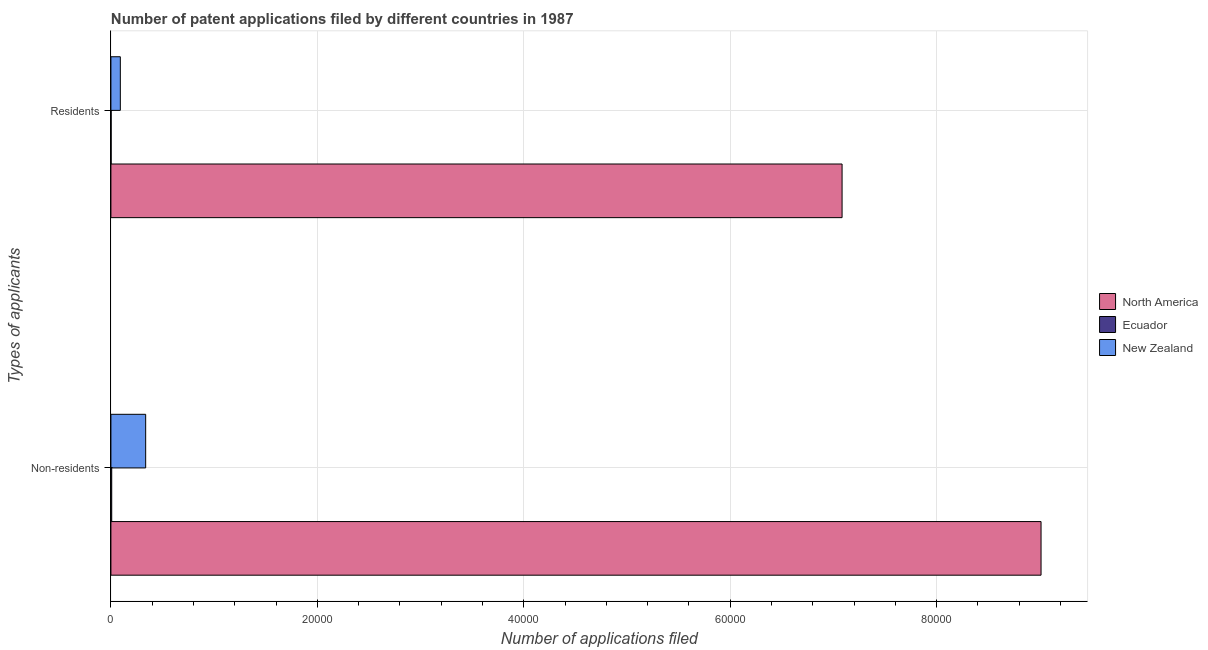How many different coloured bars are there?
Give a very brief answer. 3. How many bars are there on the 2nd tick from the top?
Give a very brief answer. 3. How many bars are there on the 2nd tick from the bottom?
Keep it short and to the point. 3. What is the label of the 1st group of bars from the top?
Keep it short and to the point. Residents. What is the number of patent applications by non residents in North America?
Make the answer very short. 9.01e+04. Across all countries, what is the maximum number of patent applications by non residents?
Provide a succinct answer. 9.01e+04. Across all countries, what is the minimum number of patent applications by residents?
Provide a succinct answer. 21. In which country was the number of patent applications by non residents minimum?
Your answer should be compact. Ecuador. What is the total number of patent applications by non residents in the graph?
Make the answer very short. 9.36e+04. What is the difference between the number of patent applications by residents in North America and that in Ecuador?
Keep it short and to the point. 7.08e+04. What is the difference between the number of patent applications by residents in New Zealand and the number of patent applications by non residents in Ecuador?
Your answer should be very brief. 834. What is the average number of patent applications by non residents per country?
Provide a succinct answer. 3.12e+04. What is the difference between the number of patent applications by non residents and number of patent applications by residents in Ecuador?
Give a very brief answer. 57. What is the ratio of the number of patent applications by residents in New Zealand to that in Ecuador?
Your answer should be compact. 43.43. Is the number of patent applications by non residents in Ecuador less than that in North America?
Offer a very short reply. Yes. What does the 1st bar from the top in Residents represents?
Make the answer very short. New Zealand. What does the 3rd bar from the bottom in Non-residents represents?
Offer a terse response. New Zealand. How many bars are there?
Offer a terse response. 6. How many countries are there in the graph?
Make the answer very short. 3. What is the difference between two consecutive major ticks on the X-axis?
Give a very brief answer. 2.00e+04. Does the graph contain any zero values?
Provide a short and direct response. No. Does the graph contain grids?
Keep it short and to the point. Yes. Where does the legend appear in the graph?
Make the answer very short. Center right. How many legend labels are there?
Ensure brevity in your answer.  3. How are the legend labels stacked?
Your answer should be very brief. Vertical. What is the title of the graph?
Keep it short and to the point. Number of patent applications filed by different countries in 1987. What is the label or title of the X-axis?
Make the answer very short. Number of applications filed. What is the label or title of the Y-axis?
Provide a succinct answer. Types of applicants. What is the Number of applications filed in North America in Non-residents?
Provide a short and direct response. 9.01e+04. What is the Number of applications filed in Ecuador in Non-residents?
Keep it short and to the point. 78. What is the Number of applications filed of New Zealand in Non-residents?
Provide a succinct answer. 3368. What is the Number of applications filed in North America in Residents?
Keep it short and to the point. 7.08e+04. What is the Number of applications filed in Ecuador in Residents?
Ensure brevity in your answer.  21. What is the Number of applications filed in New Zealand in Residents?
Give a very brief answer. 912. Across all Types of applicants, what is the maximum Number of applications filed in North America?
Keep it short and to the point. 9.01e+04. Across all Types of applicants, what is the maximum Number of applications filed of Ecuador?
Ensure brevity in your answer.  78. Across all Types of applicants, what is the maximum Number of applications filed in New Zealand?
Make the answer very short. 3368. Across all Types of applicants, what is the minimum Number of applications filed in North America?
Provide a short and direct response. 7.08e+04. Across all Types of applicants, what is the minimum Number of applications filed of Ecuador?
Your answer should be very brief. 21. Across all Types of applicants, what is the minimum Number of applications filed in New Zealand?
Keep it short and to the point. 912. What is the total Number of applications filed of North America in the graph?
Keep it short and to the point. 1.61e+05. What is the total Number of applications filed in Ecuador in the graph?
Offer a very short reply. 99. What is the total Number of applications filed in New Zealand in the graph?
Your answer should be compact. 4280. What is the difference between the Number of applications filed of North America in Non-residents and that in Residents?
Your answer should be compact. 1.93e+04. What is the difference between the Number of applications filed of New Zealand in Non-residents and that in Residents?
Give a very brief answer. 2456. What is the difference between the Number of applications filed of North America in Non-residents and the Number of applications filed of Ecuador in Residents?
Your answer should be very brief. 9.01e+04. What is the difference between the Number of applications filed of North America in Non-residents and the Number of applications filed of New Zealand in Residents?
Your response must be concise. 8.92e+04. What is the difference between the Number of applications filed in Ecuador in Non-residents and the Number of applications filed in New Zealand in Residents?
Ensure brevity in your answer.  -834. What is the average Number of applications filed of North America per Types of applicants?
Provide a succinct answer. 8.05e+04. What is the average Number of applications filed of Ecuador per Types of applicants?
Give a very brief answer. 49.5. What is the average Number of applications filed of New Zealand per Types of applicants?
Keep it short and to the point. 2140. What is the difference between the Number of applications filed in North America and Number of applications filed in Ecuador in Non-residents?
Offer a very short reply. 9.00e+04. What is the difference between the Number of applications filed in North America and Number of applications filed in New Zealand in Non-residents?
Give a very brief answer. 8.68e+04. What is the difference between the Number of applications filed of Ecuador and Number of applications filed of New Zealand in Non-residents?
Provide a short and direct response. -3290. What is the difference between the Number of applications filed of North America and Number of applications filed of Ecuador in Residents?
Give a very brief answer. 7.08e+04. What is the difference between the Number of applications filed in North America and Number of applications filed in New Zealand in Residents?
Keep it short and to the point. 6.99e+04. What is the difference between the Number of applications filed in Ecuador and Number of applications filed in New Zealand in Residents?
Your answer should be very brief. -891. What is the ratio of the Number of applications filed in North America in Non-residents to that in Residents?
Keep it short and to the point. 1.27. What is the ratio of the Number of applications filed in Ecuador in Non-residents to that in Residents?
Give a very brief answer. 3.71. What is the ratio of the Number of applications filed of New Zealand in Non-residents to that in Residents?
Offer a terse response. 3.69. What is the difference between the highest and the second highest Number of applications filed of North America?
Keep it short and to the point. 1.93e+04. What is the difference between the highest and the second highest Number of applications filed in Ecuador?
Provide a short and direct response. 57. What is the difference between the highest and the second highest Number of applications filed of New Zealand?
Provide a short and direct response. 2456. What is the difference between the highest and the lowest Number of applications filed in North America?
Provide a succinct answer. 1.93e+04. What is the difference between the highest and the lowest Number of applications filed in New Zealand?
Provide a succinct answer. 2456. 